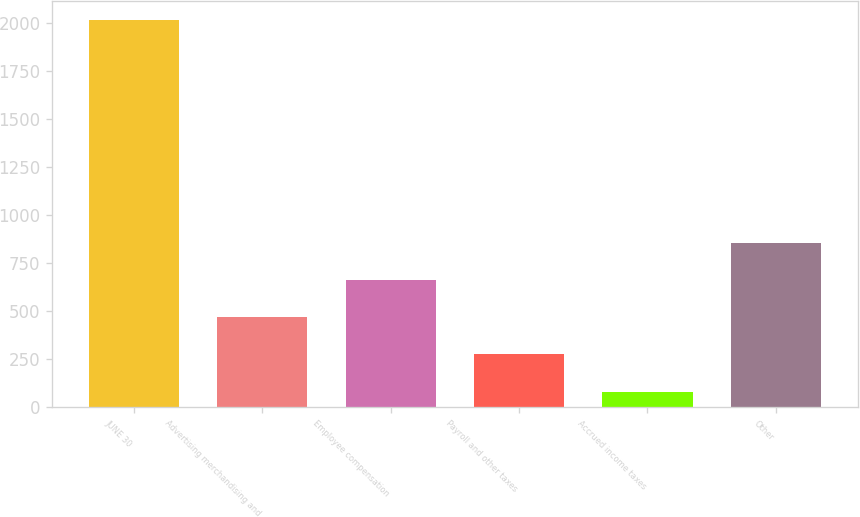Convert chart. <chart><loc_0><loc_0><loc_500><loc_500><bar_chart><fcel>JUNE 30<fcel>Advertising merchandising and<fcel>Employee compensation<fcel>Payroll and other taxes<fcel>Accrued income taxes<fcel>Other<nl><fcel>2013<fcel>467.64<fcel>660.81<fcel>274.47<fcel>81.3<fcel>853.98<nl></chart> 